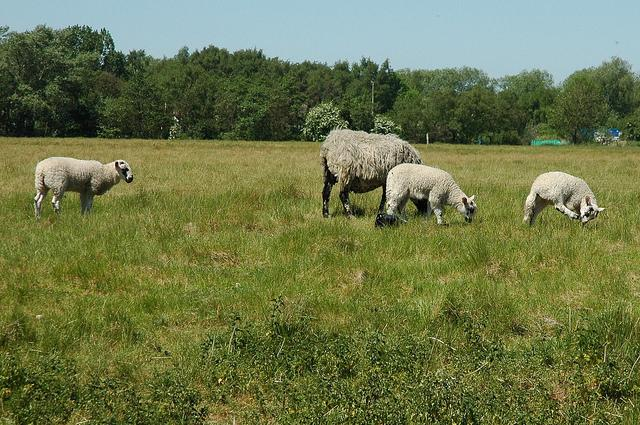What meal would these animals prefer?

Choices:
A) salad
B) fish cakes
C) venison
D) rabbit stew salad 